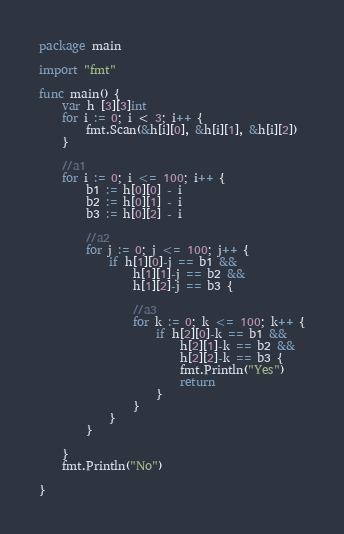Convert code to text. <code><loc_0><loc_0><loc_500><loc_500><_Go_>package main

import "fmt"

func main() {
	var h [3][3]int
	for i := 0; i < 3; i++ {
		fmt.Scan(&h[i][0], &h[i][1], &h[i][2])
	}

	//a1
	for i := 0; i <= 100; i++ {
		b1 := h[0][0] - i
		b2 := h[0][1] - i
		b3 := h[0][2] - i

		//a2
		for j := 0; j <= 100; j++ {
			if h[1][0]-j == b1 &&
				h[1][1]-j == b2 &&
				h[1][2]-j == b3 {

				//a3
				for k := 0; k <= 100; k++ {
					if h[2][0]-k == b1 &&
						h[2][1]-k == b2 &&
						h[2][2]-k == b3 {
						fmt.Println("Yes")
						return
					}
				}
			}
		}

	}
	fmt.Println("No")

}</code> 